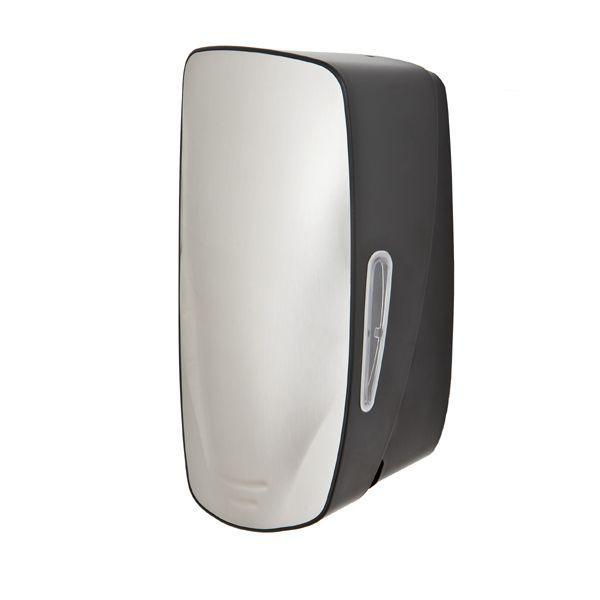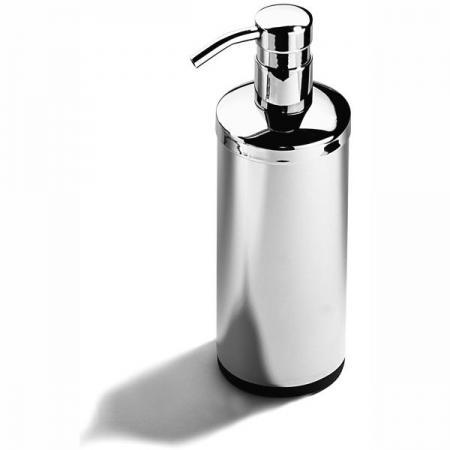The first image is the image on the left, the second image is the image on the right. Analyze the images presented: Is the assertion "One dispenser is cylinder shaped with a pump at the top." valid? Answer yes or no. Yes. 